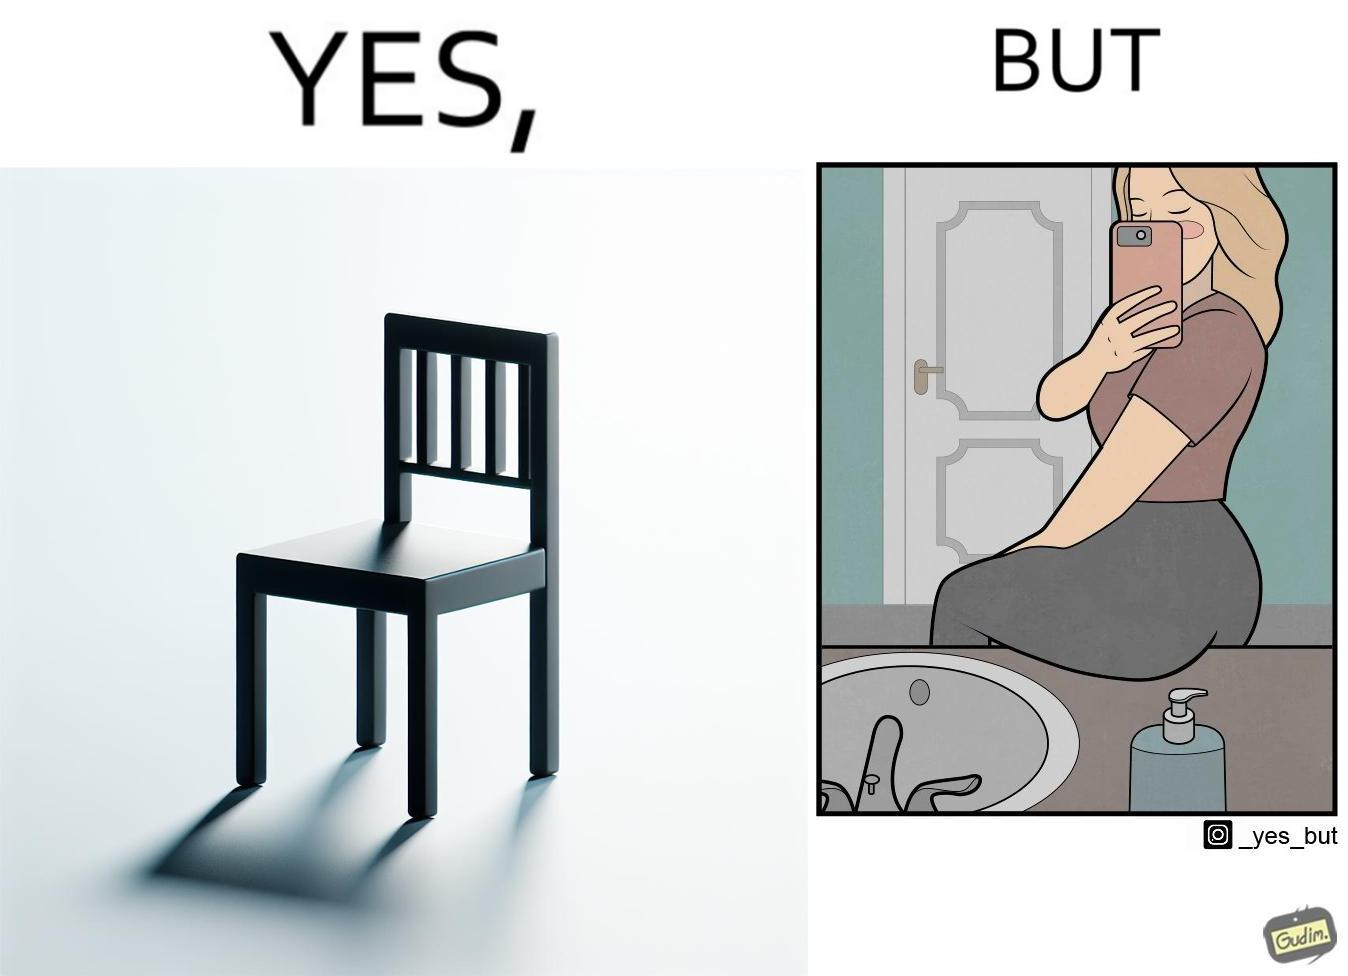Explain why this image is satirical. The image is ironical, as a woman is sitting by the sink taking a selfie using a mirror, while not using a chair that is actually meant for sitting. 